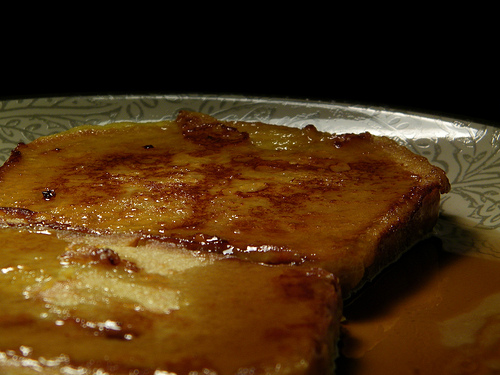<image>
Is the tart above the pan? No. The tart is not positioned above the pan. The vertical arrangement shows a different relationship. 